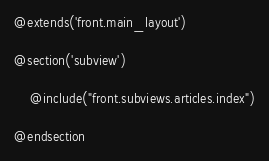<code> <loc_0><loc_0><loc_500><loc_500><_PHP_>@extends('front.main_layout')

@section('subview')

    @include("front.subviews.articles.index")

@endsection</code> 